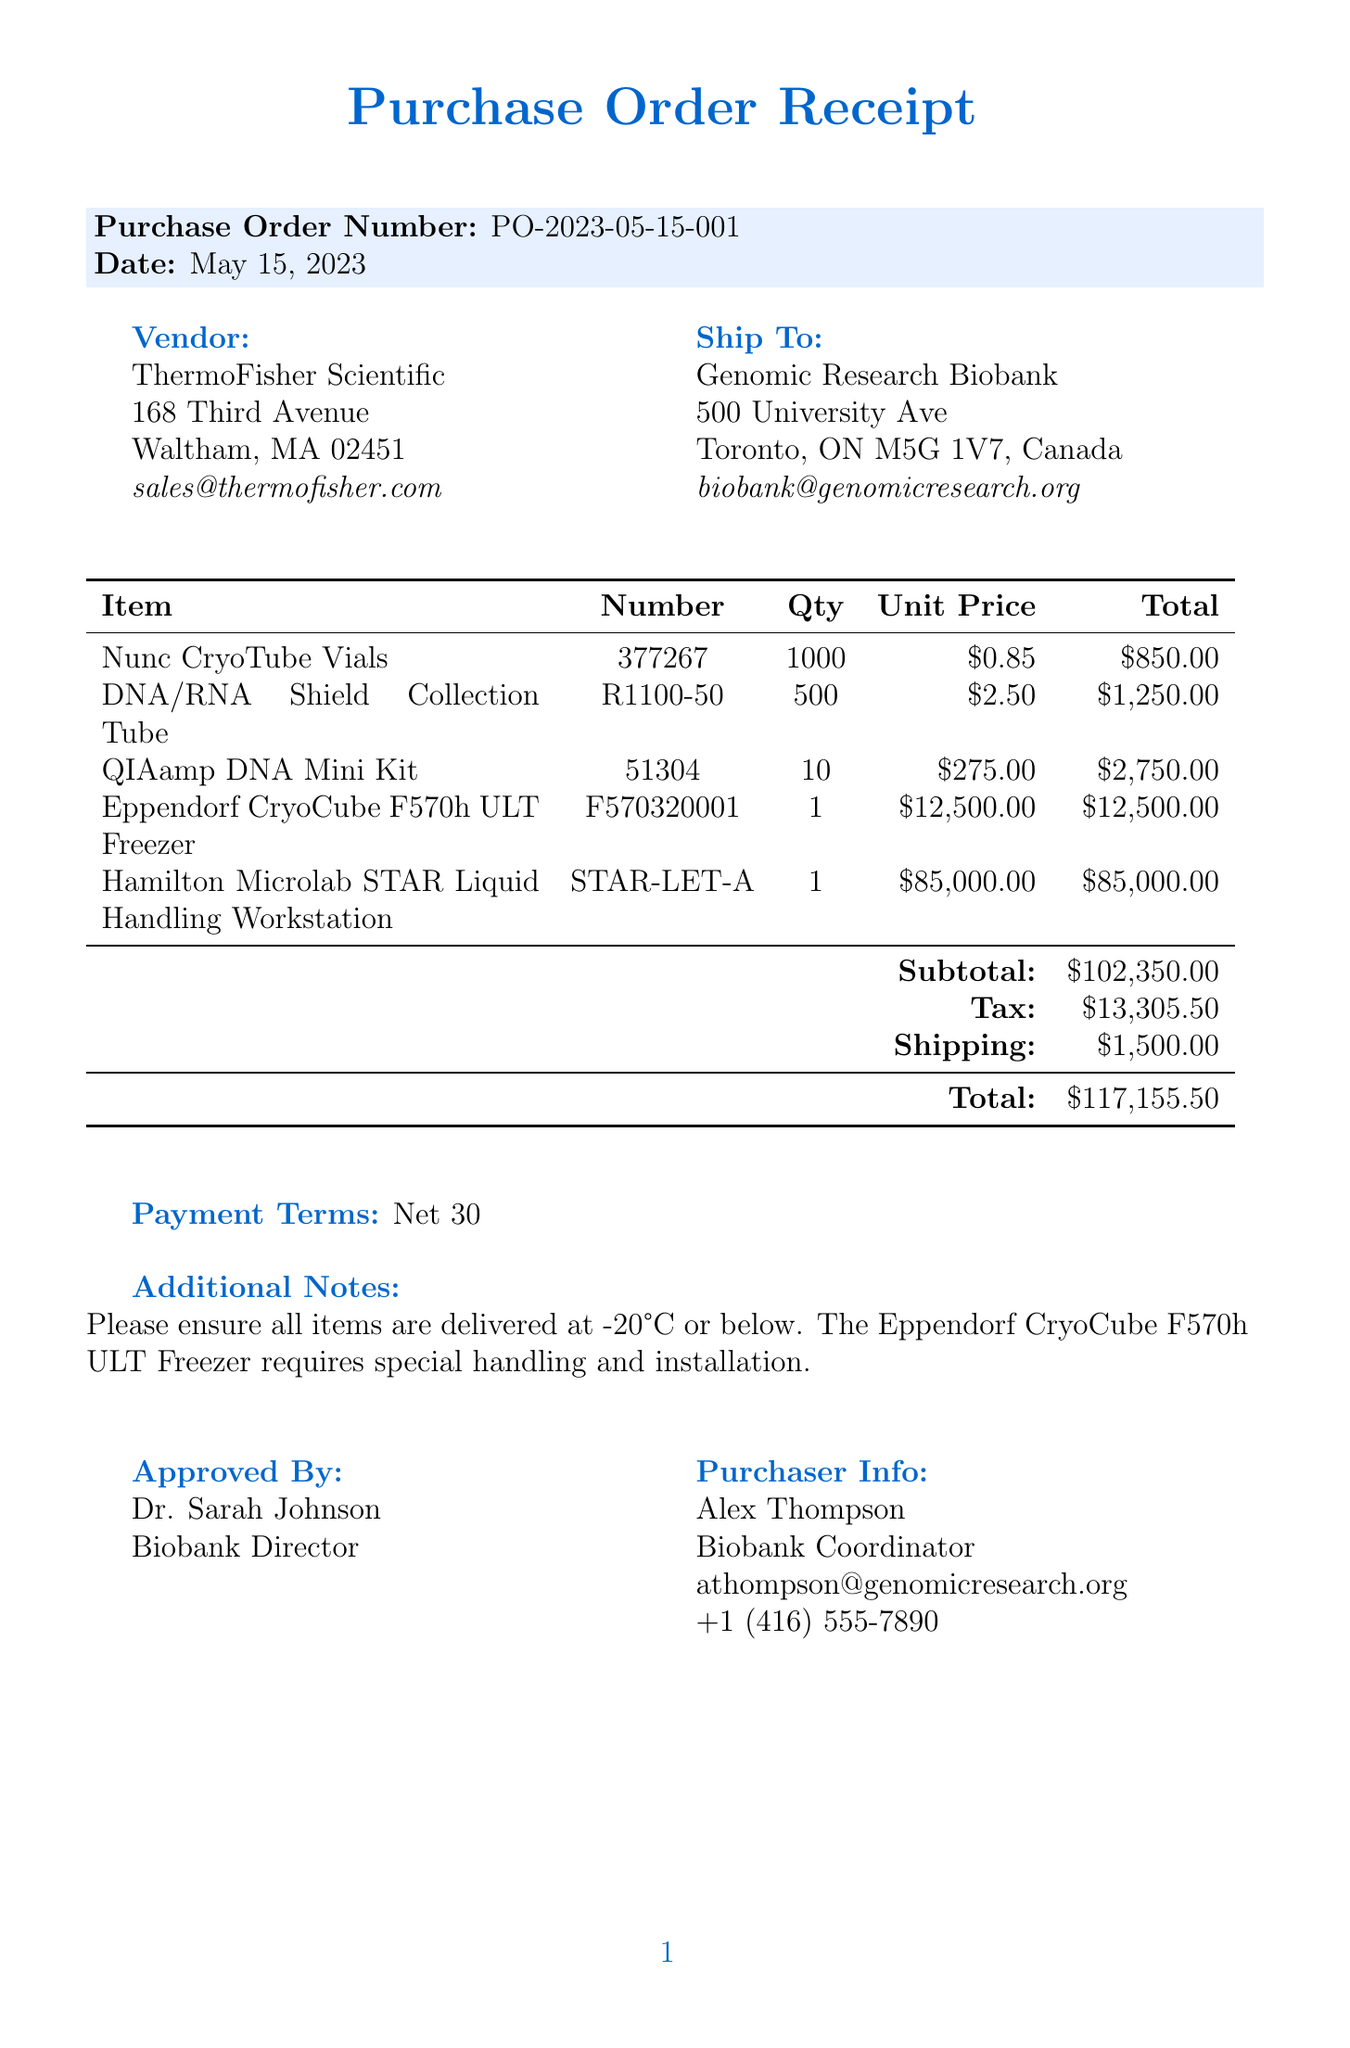What is the purchase order number? The purchase order number is stated clearly in the document under "Purchase Order Number."
Answer: PO-2023-05-15-001 Who is the vendor? The vendor's name is provided in the document, listed under the vendor section.
Answer: ThermoFisher Scientific What is the total amount of the order? The total amount is given at the end of the document, summarizing all costs including tax and shipping.
Answer: $117,155.50 How many Nunc CryoTube Vials were ordered? The quantity of Nunc CryoTube Vials is listed in the itemized purchase table within the document.
Answer: 1000 What is the unit price of the DNA/RNA Shield Collection Tube? The unit price is specified in the purchase order table for the DNA/RNA Shield Collection Tube.
Answer: $2.50 What is the shipping address for the order? The shipping address is outlined in the "Ship To" section of the document.
Answer: 500 University Ave, Toronto, ON M5G 1V7, Canada Who approved this purchase order? The name of the approver is mentioned in the document under the "Approved By" section.
Answer: Dr. Sarah Johnson What are the payment terms? The payment terms are given in a specific section of the document regarding financial agreements.
Answer: Net 30 What special handling instruction is noted for the Eppendorf CryoCube Freezer? The document states additional notes about specific handling for the Eppendorf CryoCube F570h ULT Freezer.
Answer: Requires special handling and installation 